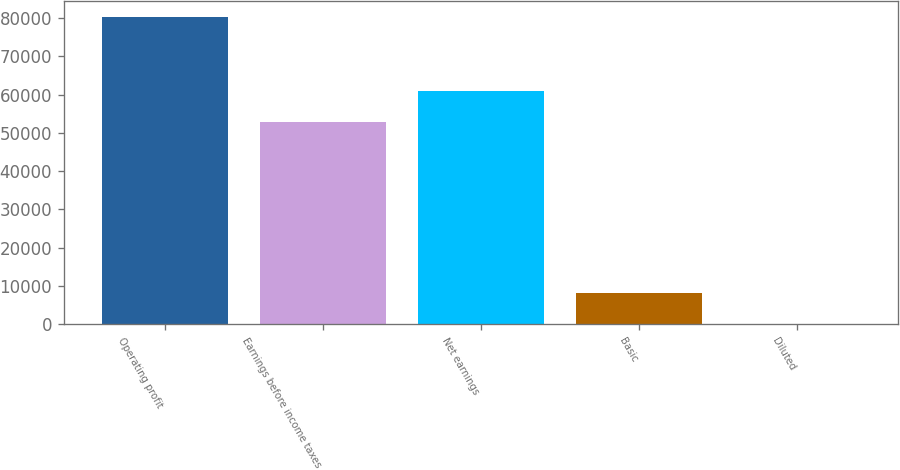Convert chart to OTSL. <chart><loc_0><loc_0><loc_500><loc_500><bar_chart><fcel>Operating profit<fcel>Earnings before income taxes<fcel>Net earnings<fcel>Basic<fcel>Diluted<nl><fcel>80407<fcel>52954<fcel>60994.7<fcel>8041.08<fcel>0.42<nl></chart> 